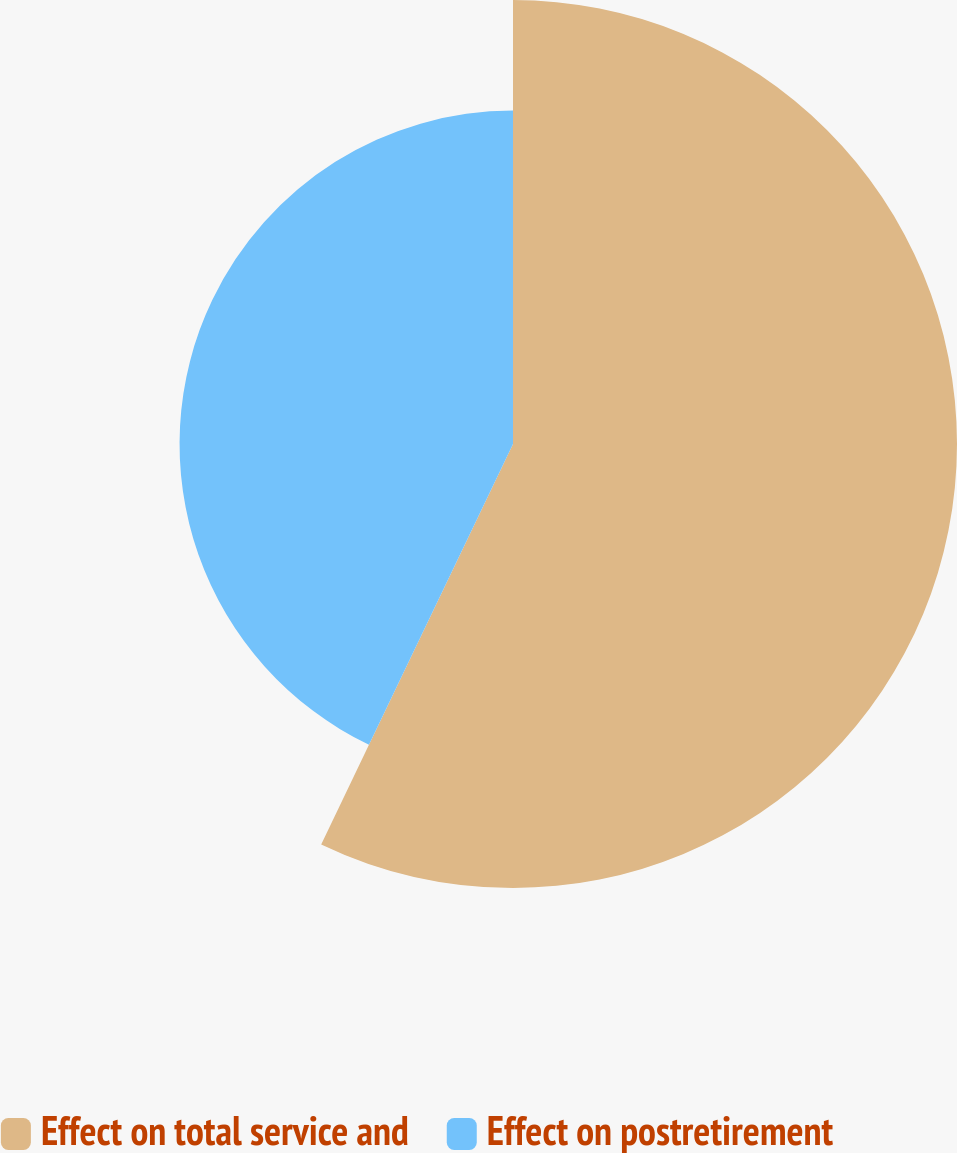<chart> <loc_0><loc_0><loc_500><loc_500><pie_chart><fcel>Effect on total service and<fcel>Effect on postretirement<nl><fcel>57.11%<fcel>42.89%<nl></chart> 